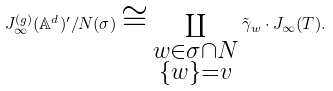<formula> <loc_0><loc_0><loc_500><loc_500>J _ { \infty } ^ { ( g ) } ( \mathbb { A } ^ { d } ) ^ { \prime } / N ( \sigma ) \cong \coprod _ { \substack { w \in \sigma \cap N \\ \{ w \} = v } } \tilde { \gamma } _ { w } \cdot J _ { \infty } ( T ) .</formula> 